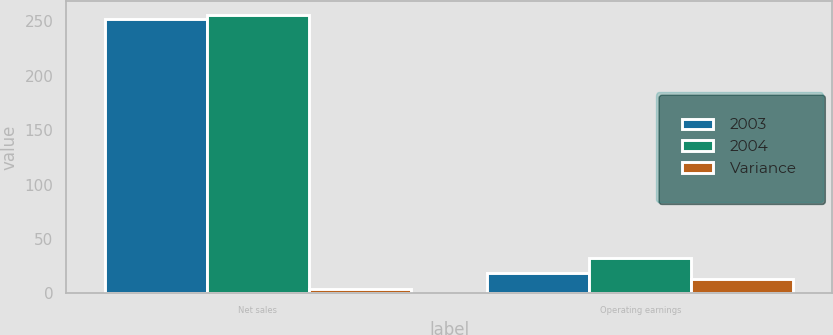<chart> <loc_0><loc_0><loc_500><loc_500><stacked_bar_chart><ecel><fcel>Net sales<fcel>Operating earnings<nl><fcel>2003<fcel>252<fcel>19<nl><fcel>2004<fcel>256<fcel>32<nl><fcel>Variance<fcel>4<fcel>13<nl></chart> 